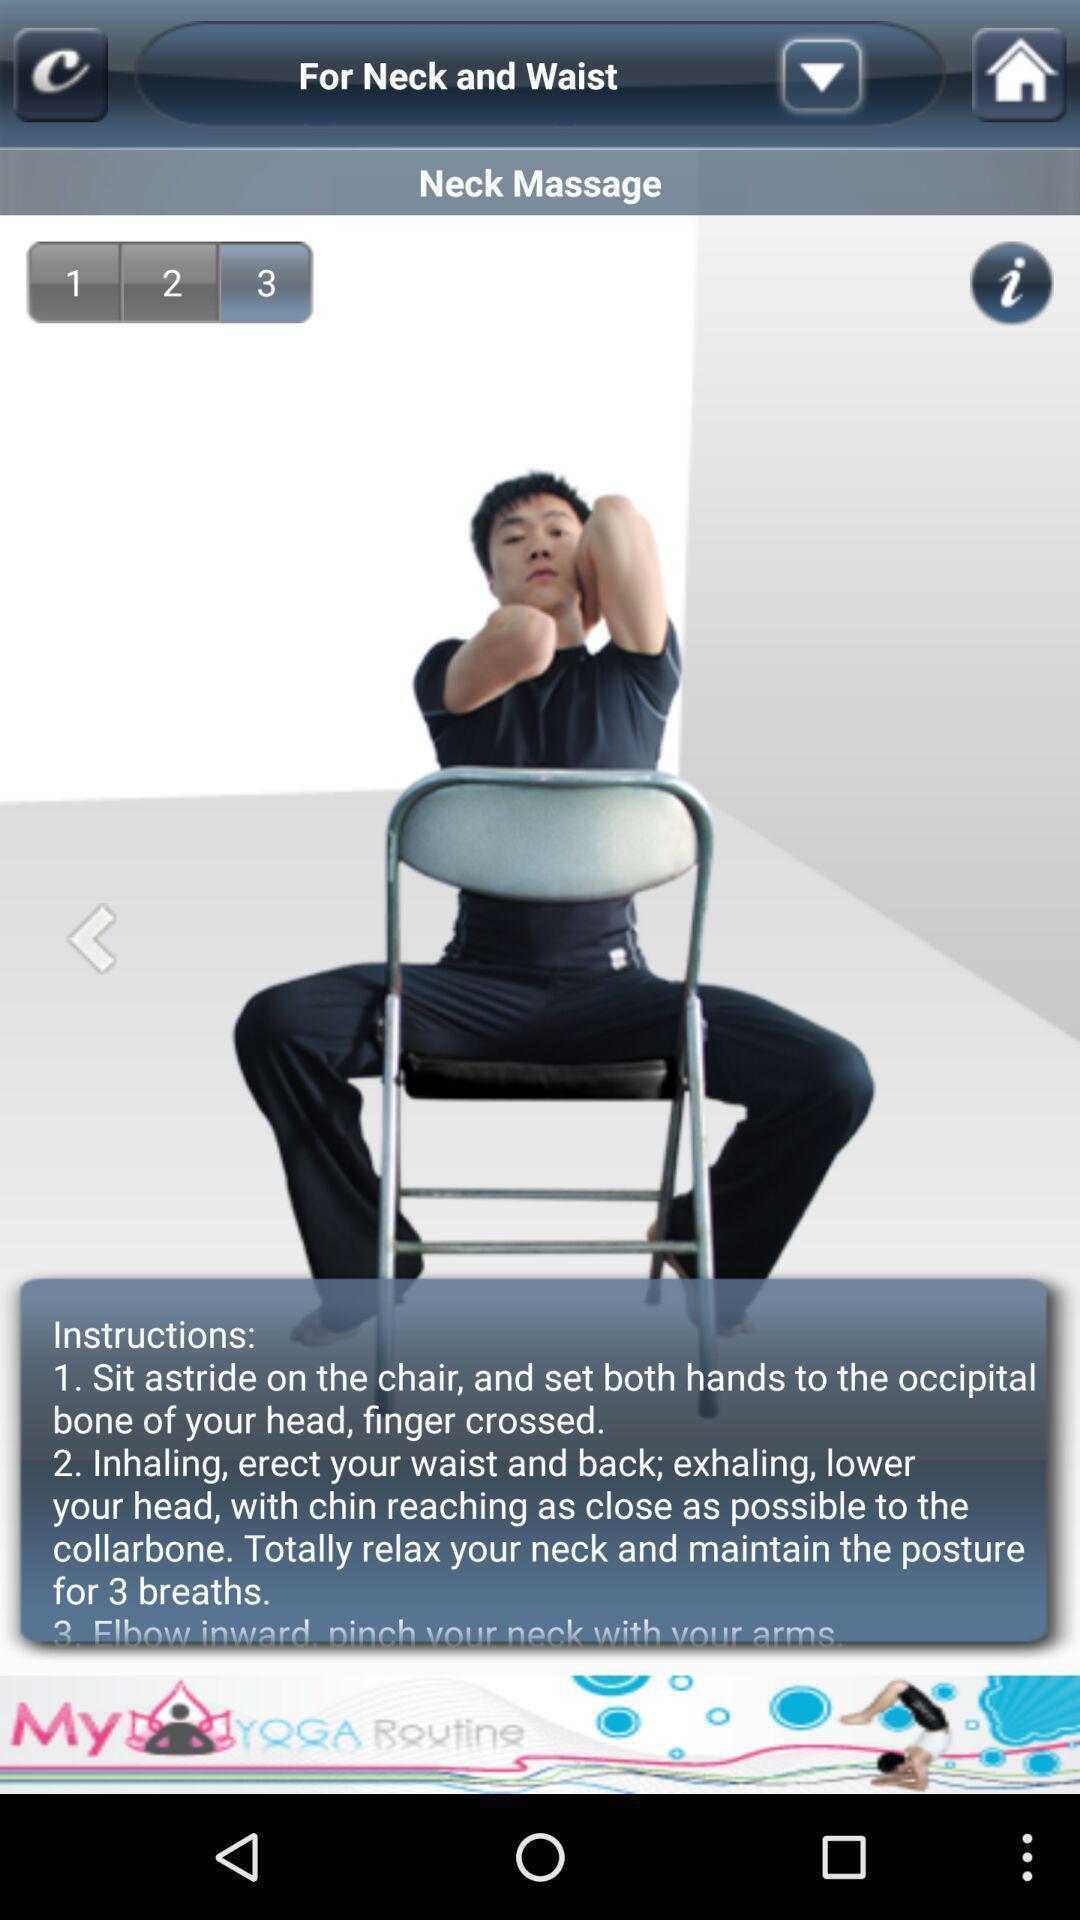Explain what's happening in this screen capture. Page with instruction of an exercise. 